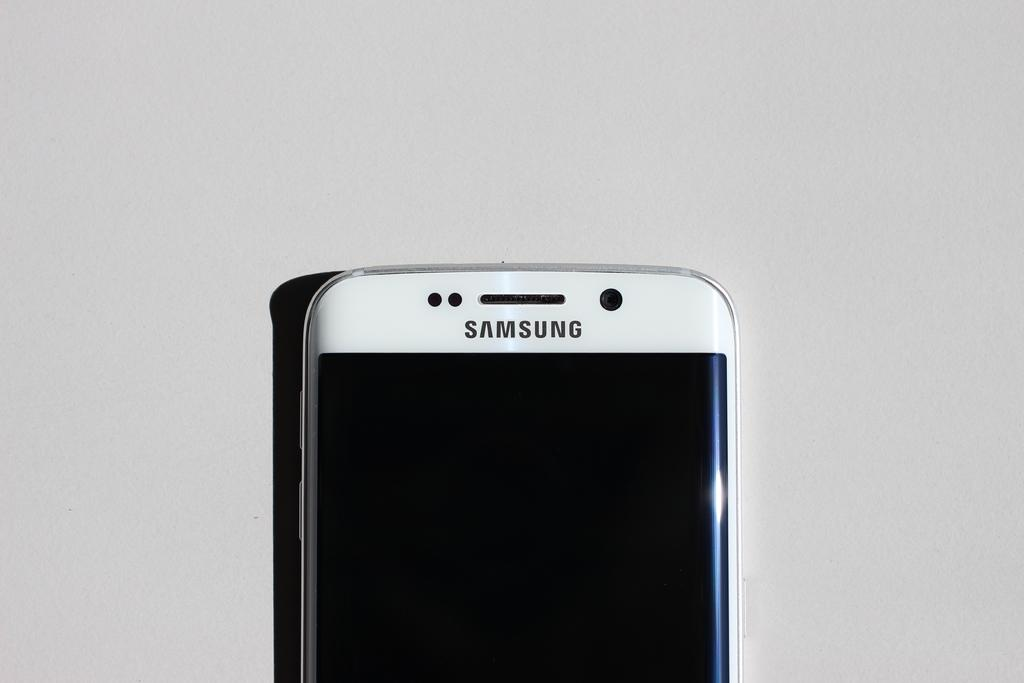<image>
Summarize the visual content of the image. The white mobile phone shown is by the brand Samsung. 